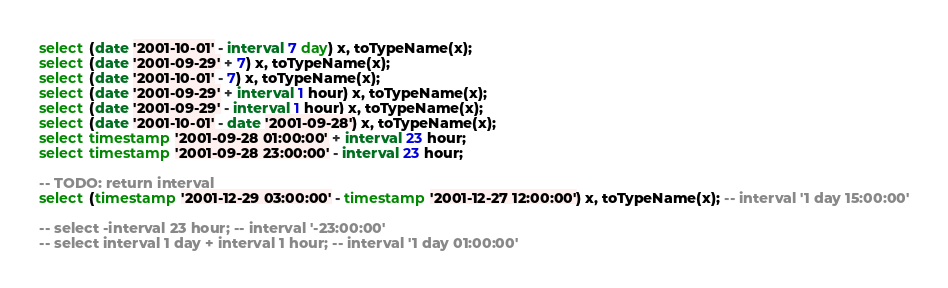<code> <loc_0><loc_0><loc_500><loc_500><_SQL_>select (date '2001-10-01' - interval 7 day) x, toTypeName(x);
select (date '2001-09-29' + 7) x, toTypeName(x);
select (date '2001-10-01' - 7) x, toTypeName(x);
select (date '2001-09-29' + interval 1 hour) x, toTypeName(x);
select (date '2001-09-29' - interval 1 hour) x, toTypeName(x);
select (date '2001-10-01' - date '2001-09-28') x, toTypeName(x);
select timestamp '2001-09-28 01:00:00' + interval 23 hour;
select timestamp '2001-09-28 23:00:00' - interval 23 hour;

-- TODO: return interval
select (timestamp '2001-12-29 03:00:00' - timestamp '2001-12-27 12:00:00') x, toTypeName(x); -- interval '1 day 15:00:00'

-- select -interval 23 hour; -- interval '-23:00:00'
-- select interval 1 day + interval 1 hour; -- interval '1 day 01:00:00'</code> 